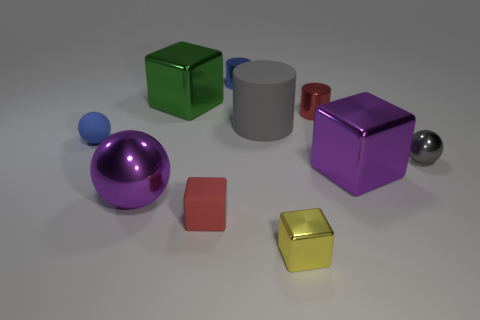Subtract all metallic cubes. How many cubes are left? 1 Subtract all purple blocks. How many blocks are left? 3 Subtract all spheres. How many objects are left? 7 Subtract all blue blocks. Subtract all cyan cylinders. How many blocks are left? 4 Subtract all green spheres. How many cyan cylinders are left? 0 Subtract all big blue metal cubes. Subtract all metal cubes. How many objects are left? 7 Add 8 yellow metal objects. How many yellow metal objects are left? 9 Add 10 big red matte spheres. How many big red matte spheres exist? 10 Subtract 0 yellow cylinders. How many objects are left? 10 Subtract 1 cylinders. How many cylinders are left? 2 